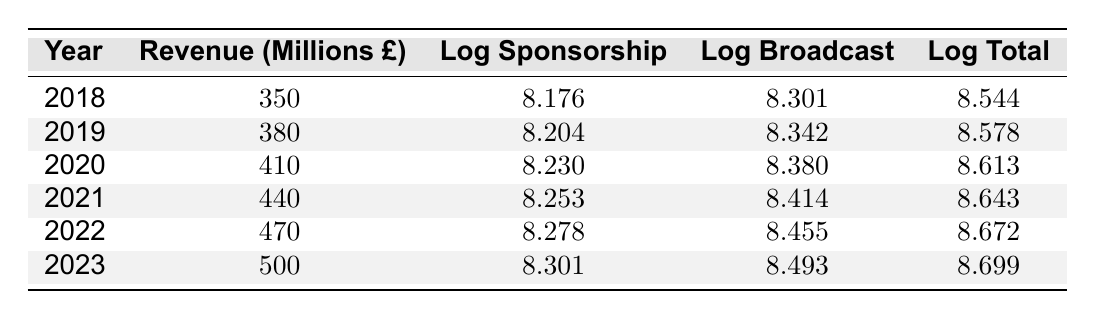What was the total revenue for the year 2022? In the table, locate the row for the year 2022, which has the total revenue column labeled. The value for total revenue for 2022 is 470 million pounds.
Answer: 470 million pounds What is the logarithmic value of broadcast revenue for 2020? Find the row for the year 2020 in the table, and then look for the column labeled log broadcast revenue. The value given there is 8.380.
Answer: 8.380 Was the total revenue higher in 2021 than in 2019? To answer this, check the total revenue values for both years in the table. The total revenue for 2021 is 440 million pounds and for 2019 it is 380 million pounds. Since 440 million is greater than 380 million, the statement is true.
Answer: Yes What is the average sponsorship revenue from 2018 to 2023? Add up the sponsorship revenues from 2018 (150 million), 2019 (160 million), 2020 (170 million), 2021 (180 million), 2022 (190 million), and 2023 (200 million), which totals 1050 million. Then divide by the number of years, which is 6. The average is 1050 million / 6 = 175 million.
Answer: 175 million In which year was the total revenue the highest, and what was that amount? Scan the total revenue column across all years in the table. The highest value appears in the year 2023, where the total revenue is 500 million pounds.
Answer: 2023, 500 million pounds Is the logarithmic sponsorship revenue for 2021 greater than that for 2020? Check the log sponsorship revenue values for both years. The value for 2021 is 8.253 and for 2020 is 8.230. Since 8.253 is greater than 8.230, the statement is true.
Answer: Yes What is the increase in total revenue from 2019 to 2022? Find the total revenue for both years. The revenue for 2019 is 380 million pounds and for 2022 is 470 million pounds. Then calculate the difference: 470 million - 380 million equals 90 million.
Answer: 90 million Which year experienced the least increase in sponsorship revenue compared to the previous year? Examine the yearly sponsorship revenues: 150 (2018), 160 (2019), 170 (2020), 180 (2021), 190 (2022), and 200 (2023). The increases are: 10 (2019), 10 (2020), 10 (2021), 10 (2022), and 10 (2023). All years have the same increase of 10 million, indicating no year experienced a smaller increase.
Answer: No year had a lesser increase 